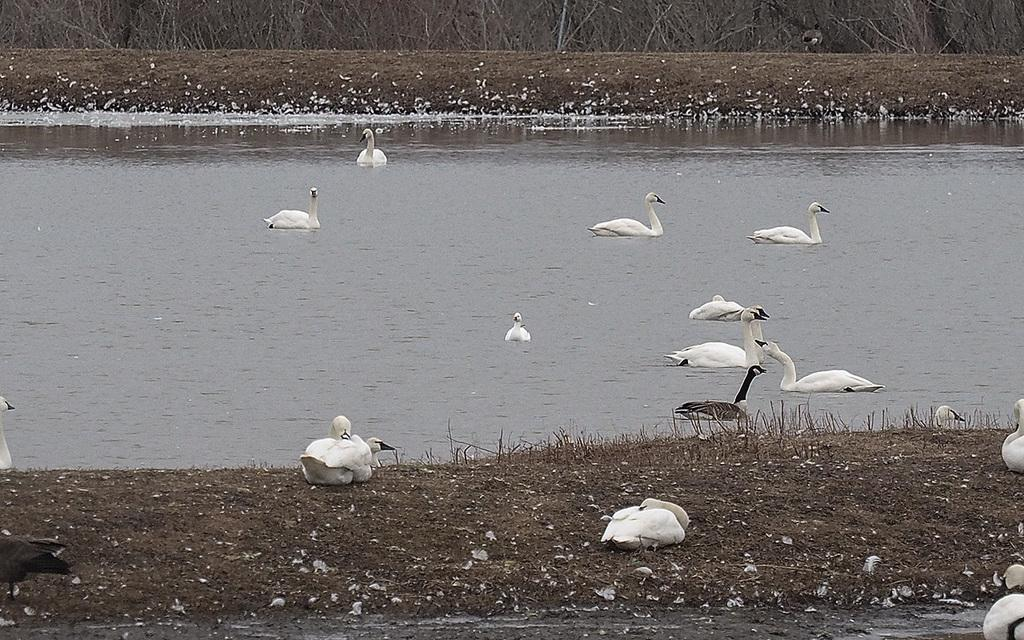What type of animals can be seen in the image? There are birds in the image. What colors are the birds in the image? The birds are in white and black color. Where are the birds located in the image? Some birds are on the ground, and some are in the water. What can be seen in the background of the image? There are dried plants in the background of the image. What type of furniture can be seen in the image? There is no furniture present in the image; it features birds in white and black color, some on the ground and some in the water, with dried plants in the background. 